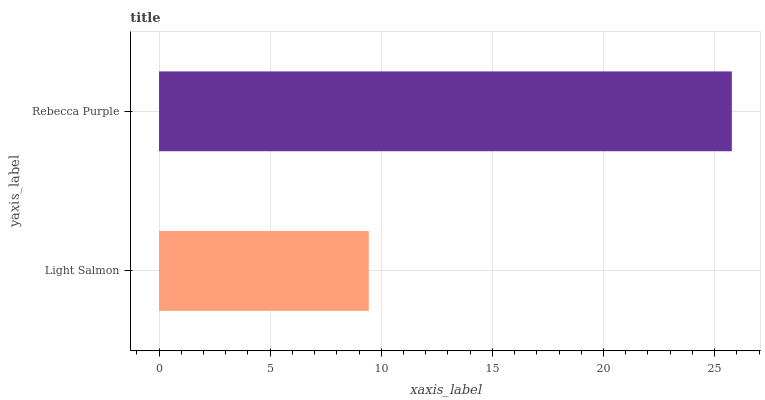Is Light Salmon the minimum?
Answer yes or no. Yes. Is Rebecca Purple the maximum?
Answer yes or no. Yes. Is Rebecca Purple the minimum?
Answer yes or no. No. Is Rebecca Purple greater than Light Salmon?
Answer yes or no. Yes. Is Light Salmon less than Rebecca Purple?
Answer yes or no. Yes. Is Light Salmon greater than Rebecca Purple?
Answer yes or no. No. Is Rebecca Purple less than Light Salmon?
Answer yes or no. No. Is Rebecca Purple the high median?
Answer yes or no. Yes. Is Light Salmon the low median?
Answer yes or no. Yes. Is Light Salmon the high median?
Answer yes or no. No. Is Rebecca Purple the low median?
Answer yes or no. No. 